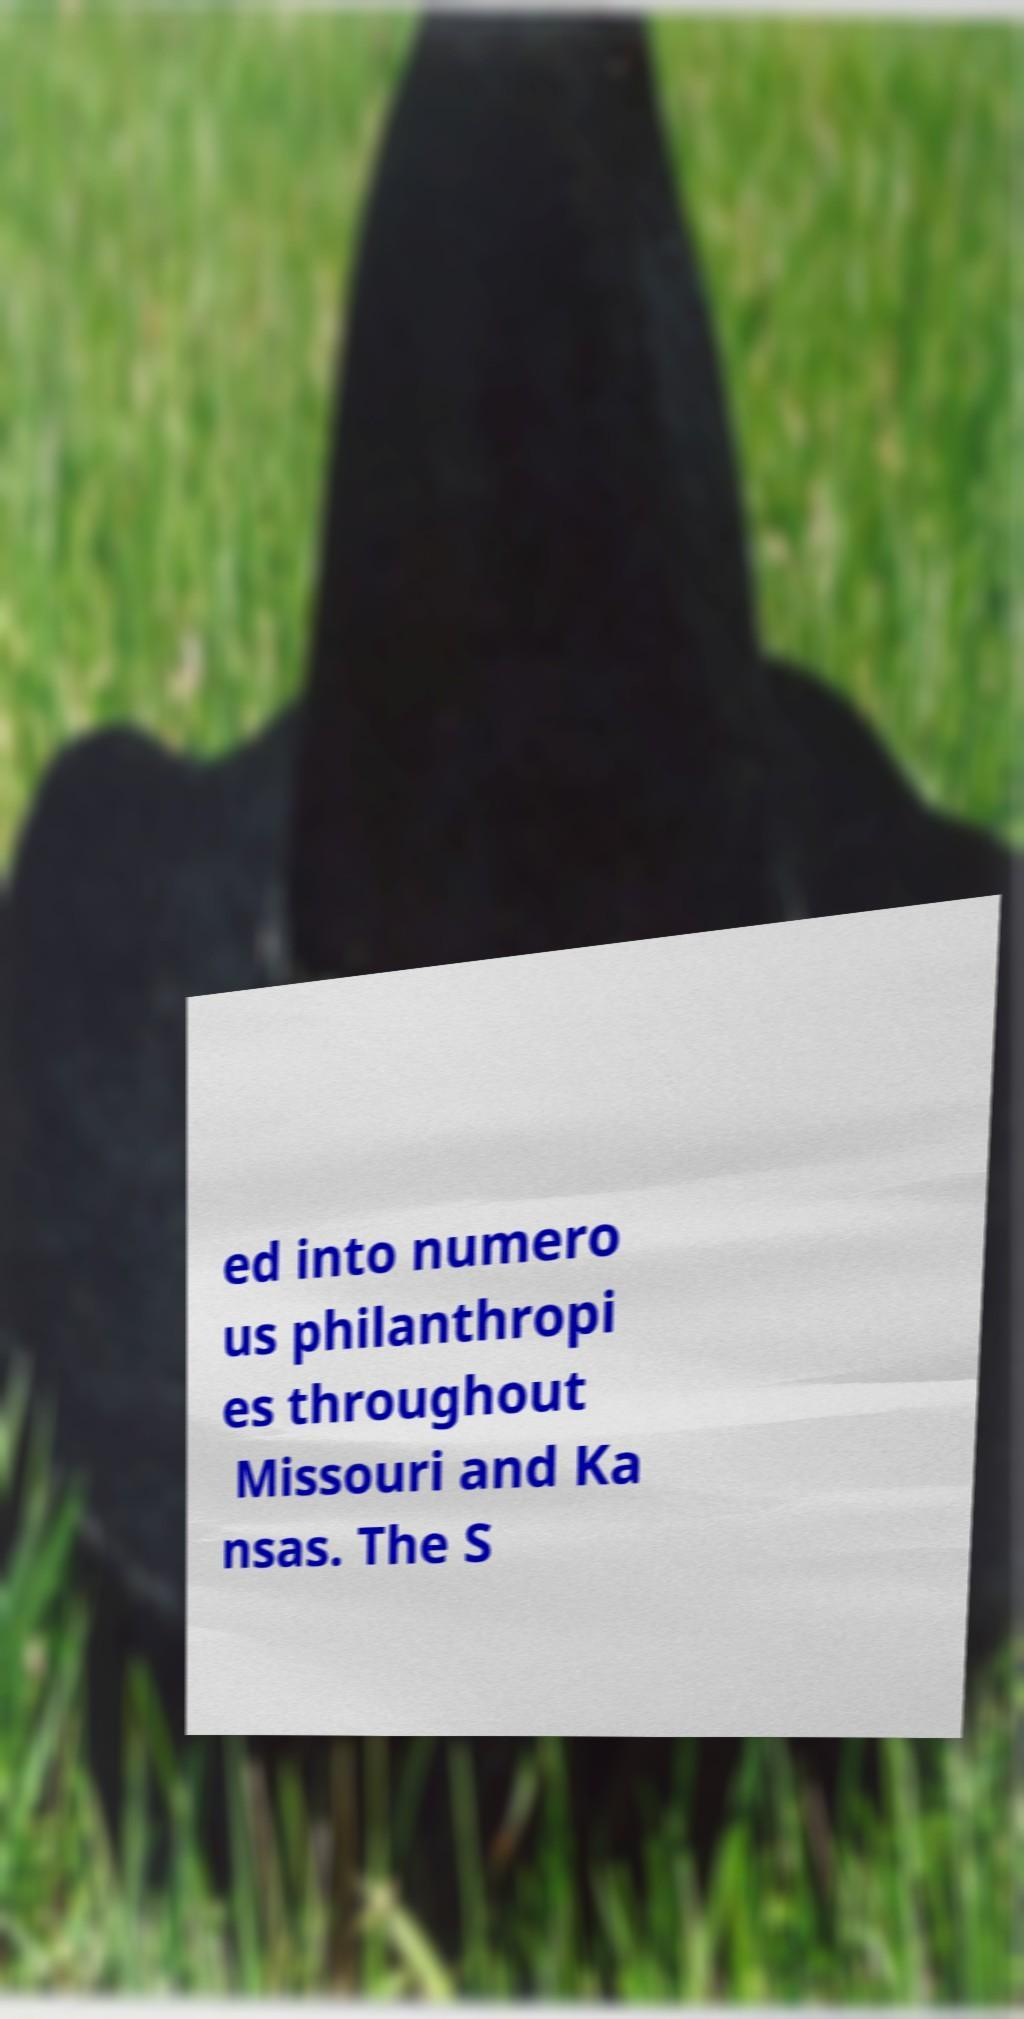Could you extract and type out the text from this image? ed into numero us philanthropi es throughout Missouri and Ka nsas. The S 